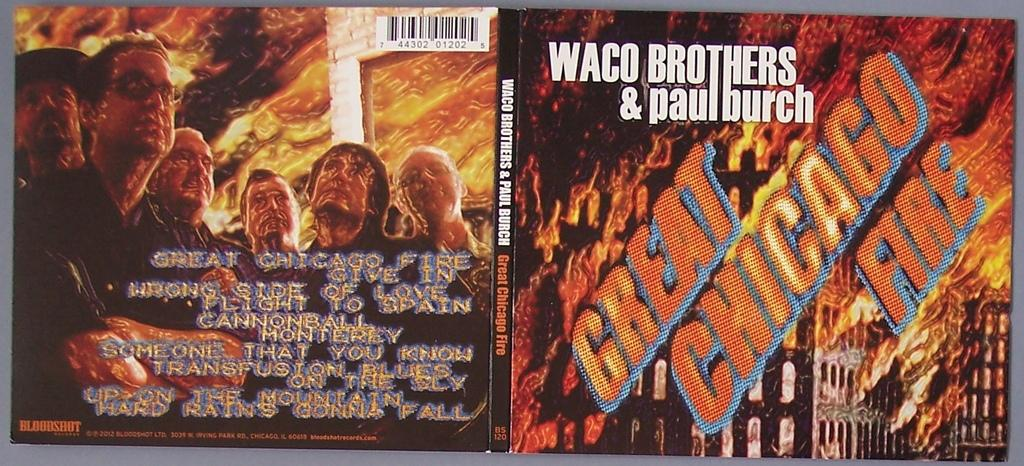<image>
Render a clear and concise summary of the photo. Waco Brothers & Paul Burch cover cd for the Great Chicago fire 